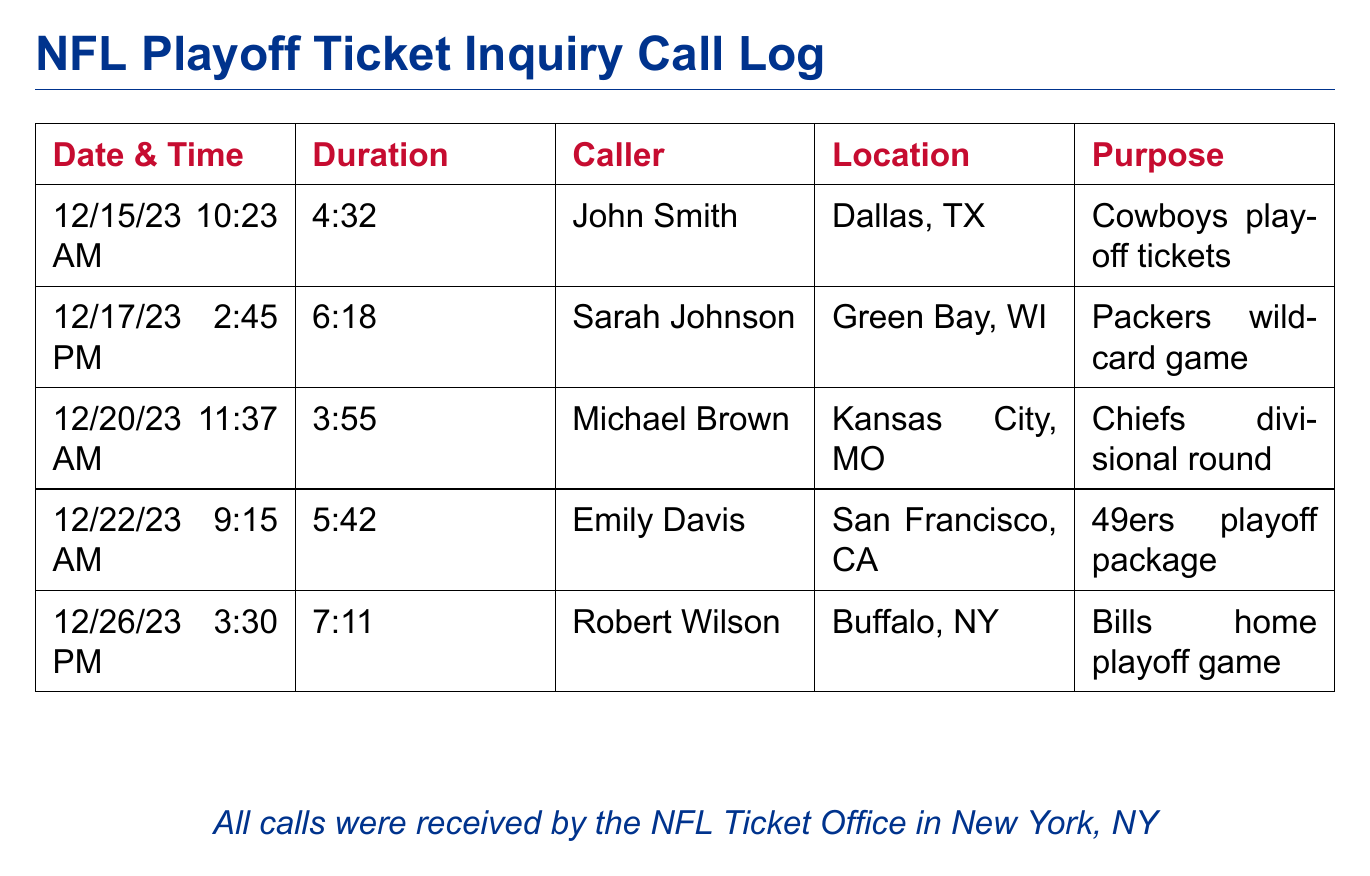What is the date and time of the first call? The first call occurred on 12/15/23 at 10:23 AM.
Answer: 12/15/23 10:23 AM Who made the call on 12/22/23? The call on 12/22/23 was made by Emily Davis.
Answer: Emily Davis What was the duration of the call made by Robert Wilson? The call duration for Robert Wilson was noted as 7:11.
Answer: 7:11 Which team is associated with the call from Kansas City, MO? The call from Kansas City, MO is associated with the Chiefs divisional round.
Answer: Chiefs How many calls were made to inquire about playoff tickets? The document lists a total of 5 calls made for playoff tickets inquiries.
Answer: 5 What was the purpose of the last call logged in the document? The purpose of the last call was to inquire about the Bills home playoff game.
Answer: Bills home playoff game In which city was Sarah Johnson located when she made her call? Sarah Johnson was located in Green Bay, WI when she made her call.
Answer: Green Bay, WI What is the total duration of all calls listed? The total duration is the sum of all individual call durations. It can be calculated as follows: 4:32 + 6:18 + 3:55 + 5:42 + 7:11 = 27:38.
Answer: 27:38 